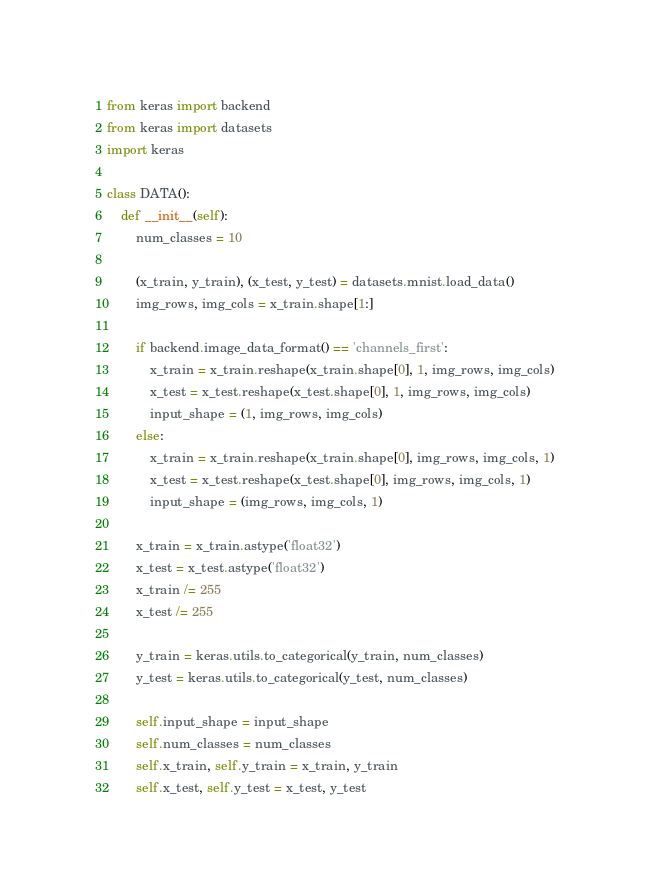<code> <loc_0><loc_0><loc_500><loc_500><_Python_>from keras import backend
from keras import datasets
import keras

class DATA():
    def __init__(self):
        num_classes = 10

        (x_train, y_train), (x_test, y_test) = datasets.mnist.load_data()
        img_rows, img_cols = x_train.shape[1:]

        if backend.image_data_format() == 'channels_first':
            x_train = x_train.reshape(x_train.shape[0], 1, img_rows, img_cols)
            x_test = x_test.reshape(x_test.shape[0], 1, img_rows, img_cols)
            input_shape = (1, img_rows, img_cols)
        else:
            x_train = x_train.reshape(x_train.shape[0], img_rows, img_cols, 1)
            x_test = x_test.reshape(x_test.shape[0], img_rows, img_cols, 1)
            input_shape = (img_rows, img_cols, 1)

        x_train = x_train.astype('float32')
        x_test = x_test.astype('float32')
        x_train /= 255
        x_test /= 255

        y_train = keras.utils.to_categorical(y_train, num_classes)
        y_test = keras.utils.to_categorical(y_test, num_classes)

        self.input_shape = input_shape
        self.num_classes = num_classes
        self.x_train, self.y_train = x_train, y_train
        self.x_test, self.y_test = x_test, y_test</code> 